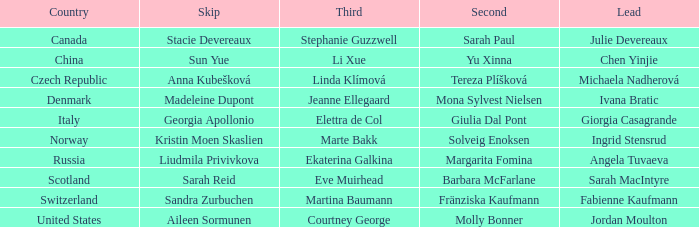What skip has martina baumann as the third? Sandra Zurbuchen. 